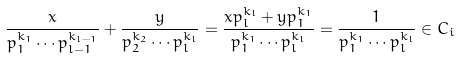Convert formula to latex. <formula><loc_0><loc_0><loc_500><loc_500>\frac { x } { p _ { 1 } ^ { k _ { 1 } } \cdots p _ { l - 1 } ^ { k _ { l - 1 } } } + \frac { y } { p _ { 2 } ^ { k _ { 2 } } \cdots p _ { l } ^ { k _ { l } } } = \frac { x p _ { l } ^ { k _ { l } } + y p _ { 1 } ^ { k _ { 1 } } } { p _ { 1 } ^ { k _ { 1 } } \cdots p _ { l } ^ { k _ { l } } } = \frac { 1 } { p _ { 1 } ^ { k _ { 1 } } \cdots p _ { l } ^ { k _ { l } } } \in C _ { i }</formula> 